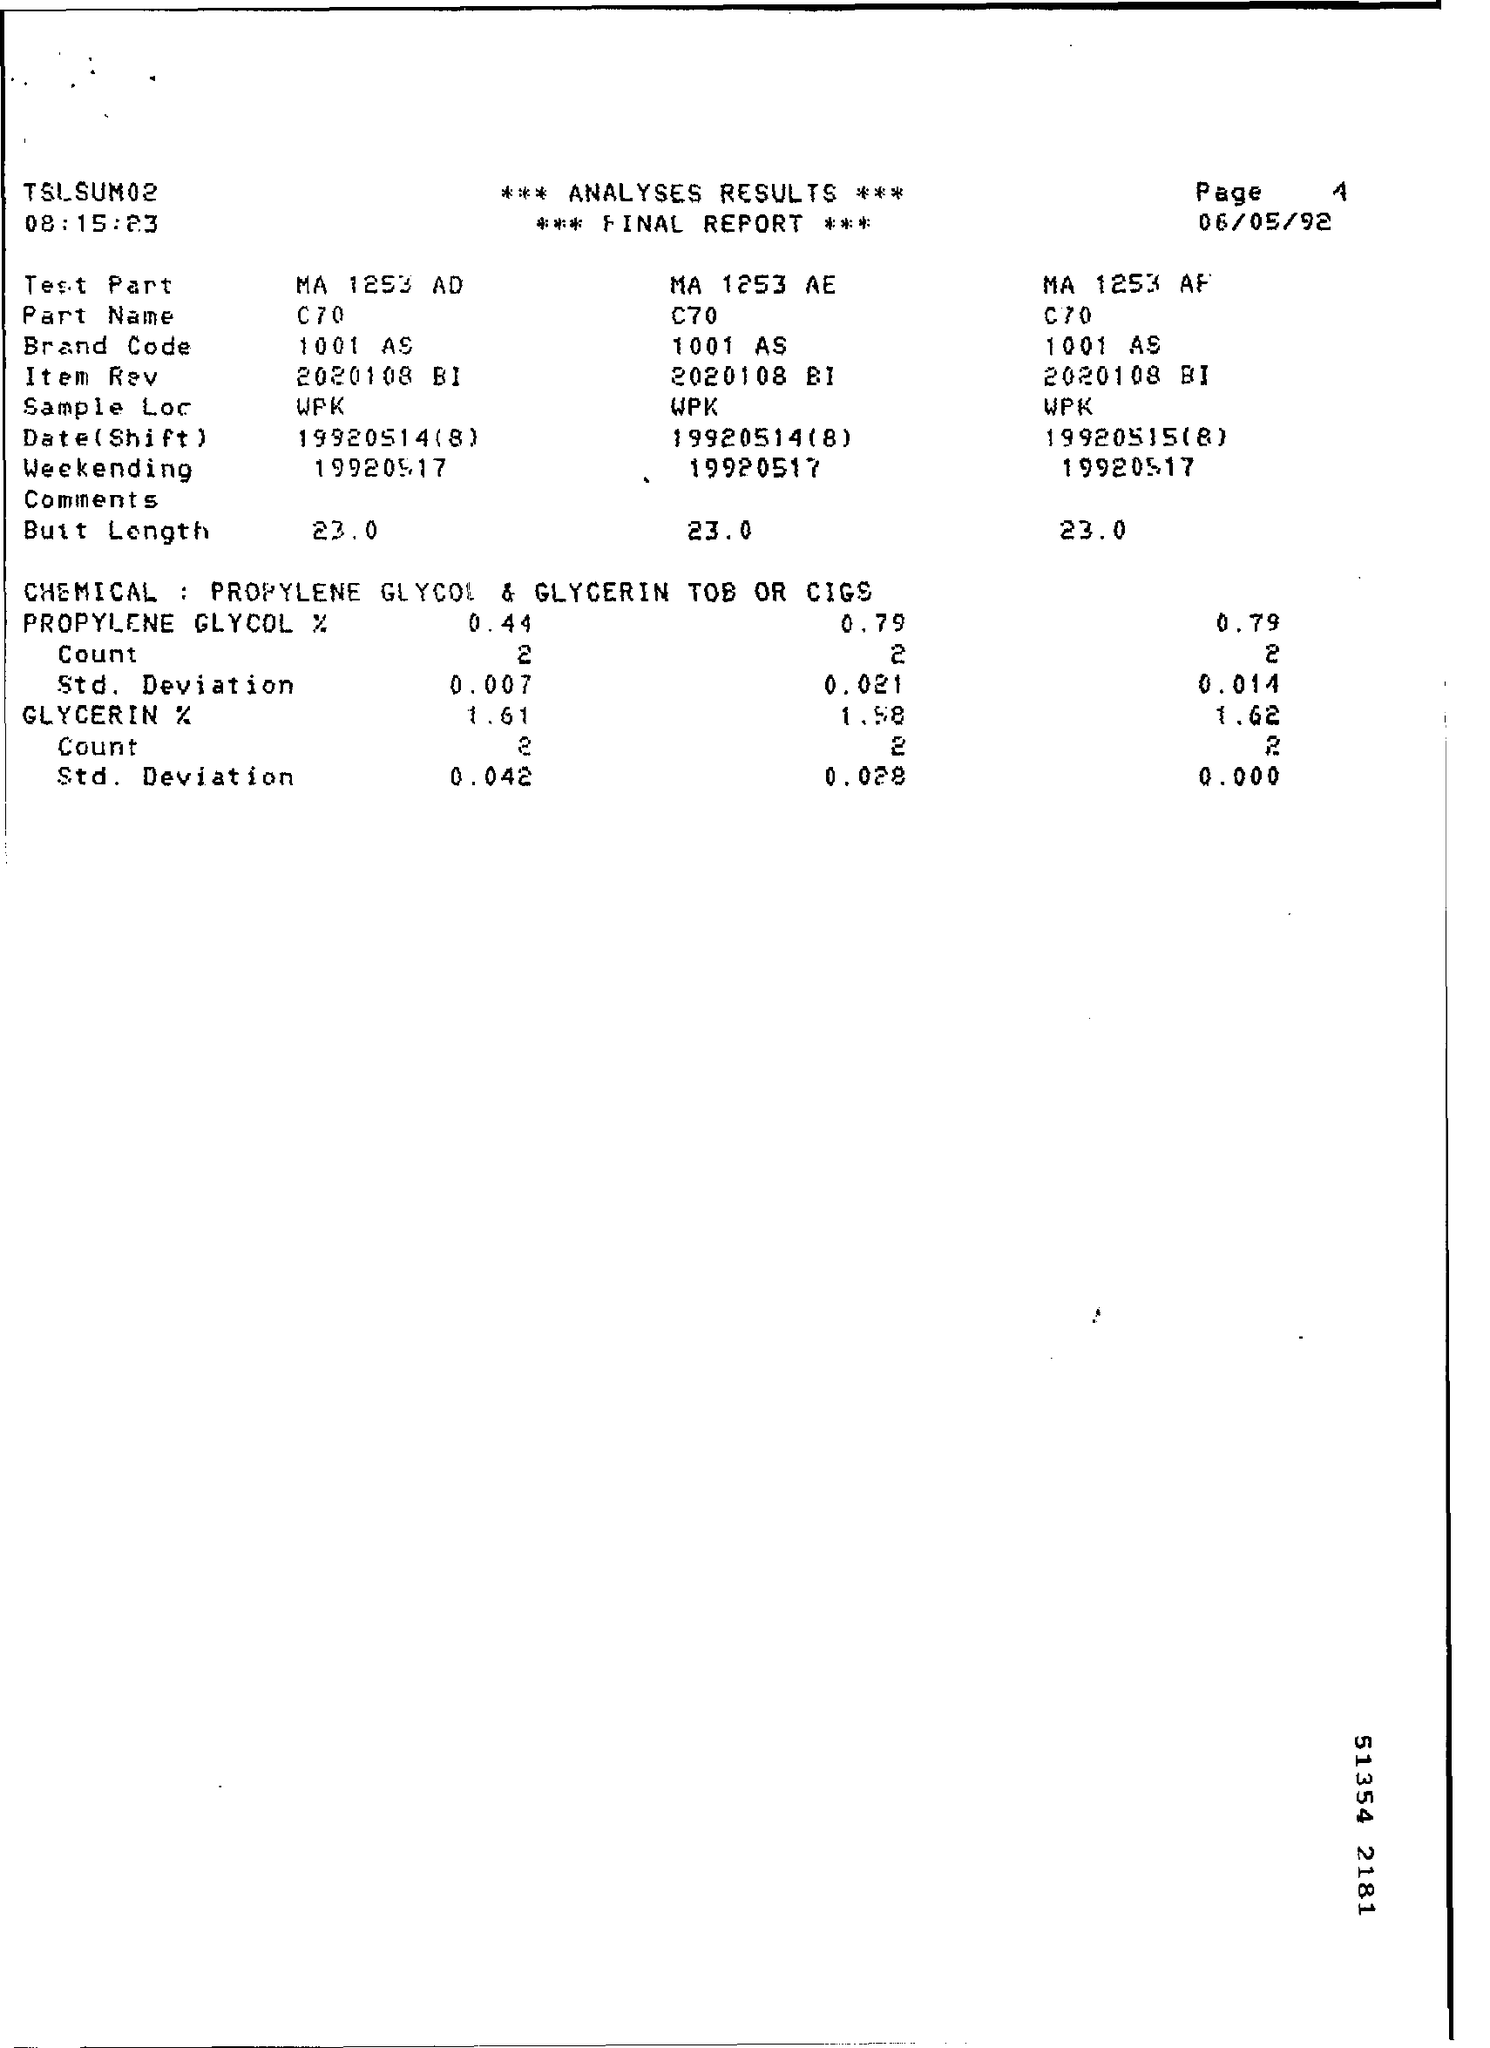What is the date mentioned ?
Your answer should be compact. 06/05/92. What is the time mentioned ?
Provide a short and direct response. 08:15:23. What is the brand code for the test part  ma 1253 ad?
Offer a terse response. 1001 AS. What is the brand code for the test part  ma 1253 ae
Keep it short and to the point. 1001 AS. What is the date(shift ) for  the test part ma1253 ad
Give a very brief answer. 19920514(8). 